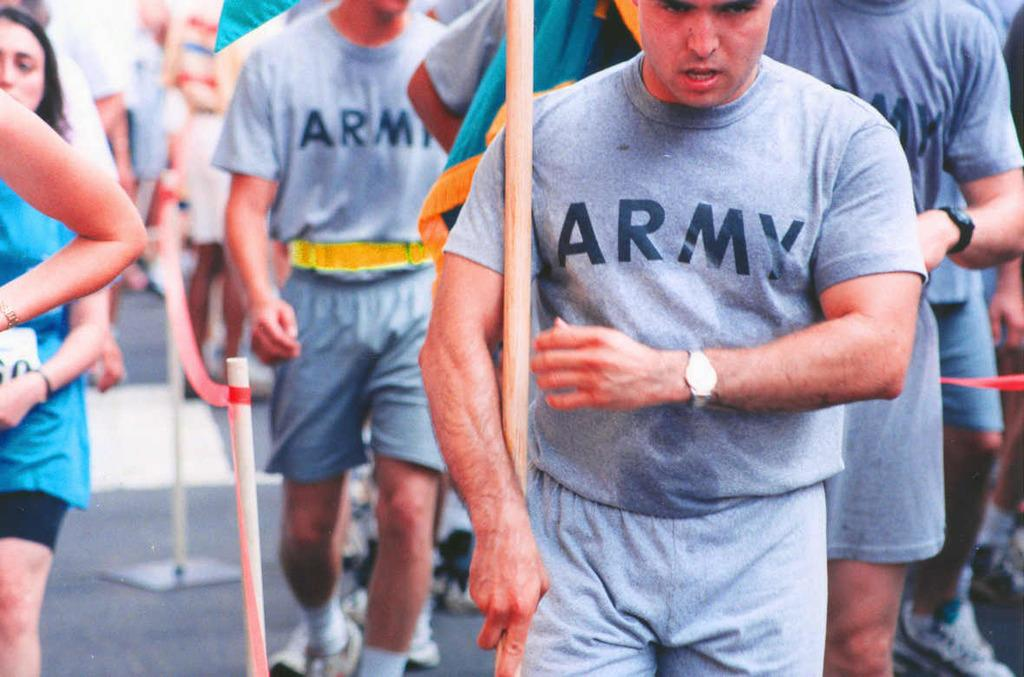<image>
Offer a succinct explanation of the picture presented. Men in Army t-shirts walking together in a crowd at a marathon. 